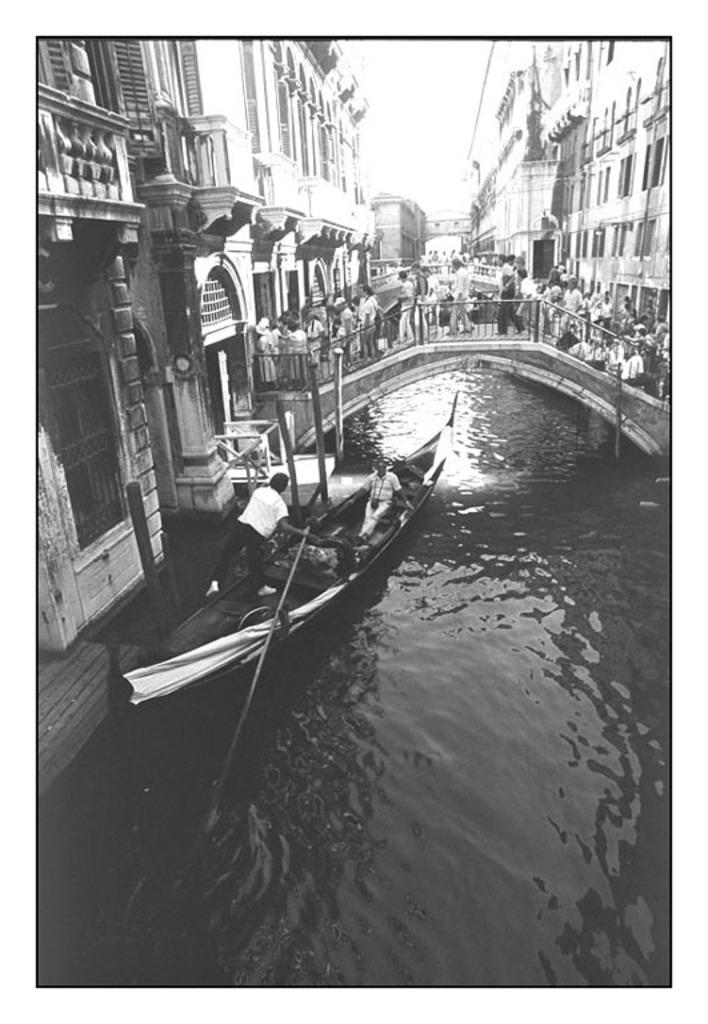Can you describe this image briefly? In this image in the center there is a boat sailing on the water with the persons inside it and in the background there is a bridge and on the bridge there are persons walking, there are buildings. On the left side there is a building and in the front there is water. 